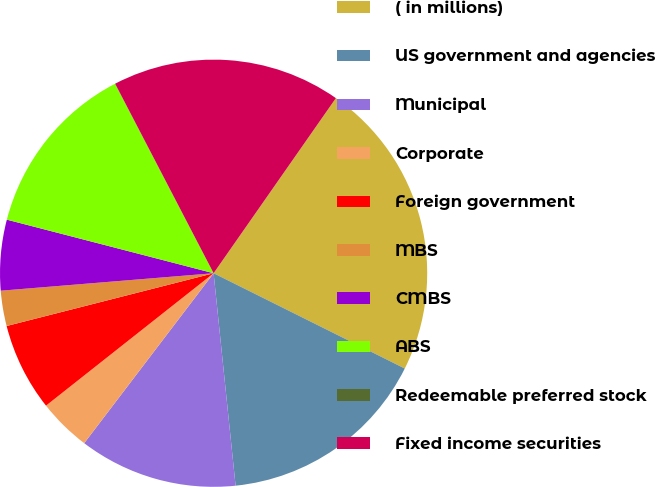<chart> <loc_0><loc_0><loc_500><loc_500><pie_chart><fcel>( in millions)<fcel>US government and agencies<fcel>Municipal<fcel>Corporate<fcel>Foreign government<fcel>MBS<fcel>CMBS<fcel>ABS<fcel>Redeemable preferred stock<fcel>Fixed income securities<nl><fcel>22.66%<fcel>16.0%<fcel>12.0%<fcel>4.0%<fcel>6.67%<fcel>2.67%<fcel>5.34%<fcel>13.33%<fcel>0.01%<fcel>17.33%<nl></chart> 